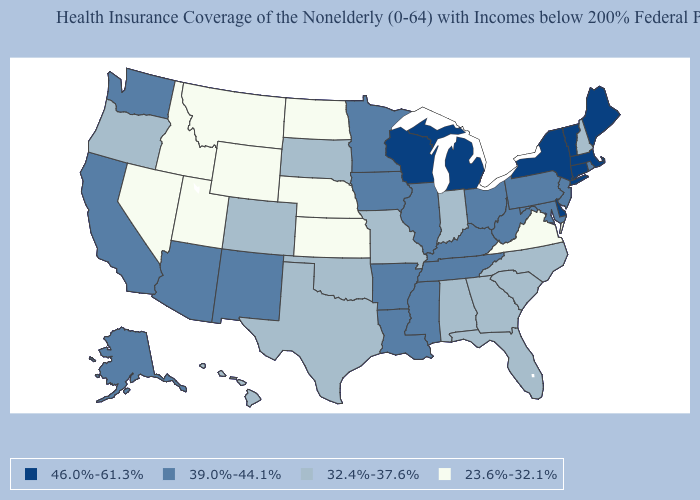Which states have the highest value in the USA?
Concise answer only. Connecticut, Delaware, Maine, Massachusetts, Michigan, New York, Vermont, Wisconsin. Does New Jersey have a lower value than Utah?
Answer briefly. No. What is the value of Washington?
Be succinct. 39.0%-44.1%. Is the legend a continuous bar?
Concise answer only. No. Which states have the lowest value in the USA?
Keep it brief. Idaho, Kansas, Montana, Nebraska, Nevada, North Dakota, Utah, Virginia, Wyoming. Among the states that border West Virginia , which have the lowest value?
Give a very brief answer. Virginia. What is the value of New Hampshire?
Quick response, please. 32.4%-37.6%. Name the states that have a value in the range 46.0%-61.3%?
Quick response, please. Connecticut, Delaware, Maine, Massachusetts, Michigan, New York, Vermont, Wisconsin. What is the value of Illinois?
Answer briefly. 39.0%-44.1%. Does the first symbol in the legend represent the smallest category?
Short answer required. No. What is the highest value in the West ?
Quick response, please. 39.0%-44.1%. Does North Dakota have a lower value than Nevada?
Be succinct. No. Is the legend a continuous bar?
Quick response, please. No. Name the states that have a value in the range 46.0%-61.3%?
Short answer required. Connecticut, Delaware, Maine, Massachusetts, Michigan, New York, Vermont, Wisconsin. Name the states that have a value in the range 39.0%-44.1%?
Short answer required. Alaska, Arizona, Arkansas, California, Illinois, Iowa, Kentucky, Louisiana, Maryland, Minnesota, Mississippi, New Jersey, New Mexico, Ohio, Pennsylvania, Rhode Island, Tennessee, Washington, West Virginia. 